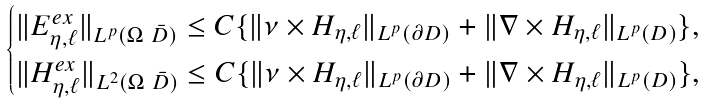<formula> <loc_0><loc_0><loc_500><loc_500>\begin{cases} \| E _ { \eta , \ell } ^ { e x } \| _ { L ^ { p } ( \Omega \ \bar { D } ) } \leq C \{ \| \nu \times H _ { \eta , \ell } \| _ { L ^ { p } ( \partial D ) } + \| \nabla \times H _ { \eta , \ell } \| _ { L ^ { p } ( D ) } \} , \\ \| H _ { \eta , \ell } ^ { e x } \| _ { L ^ { 2 } ( \Omega \ \bar { D } ) } \leq C \{ \| \nu \times H _ { \eta , \ell } \| _ { L ^ { p } ( \partial D ) } + \| \nabla \times H _ { \eta , \ell } \| _ { L ^ { p } ( D ) } \} , \end{cases}</formula> 